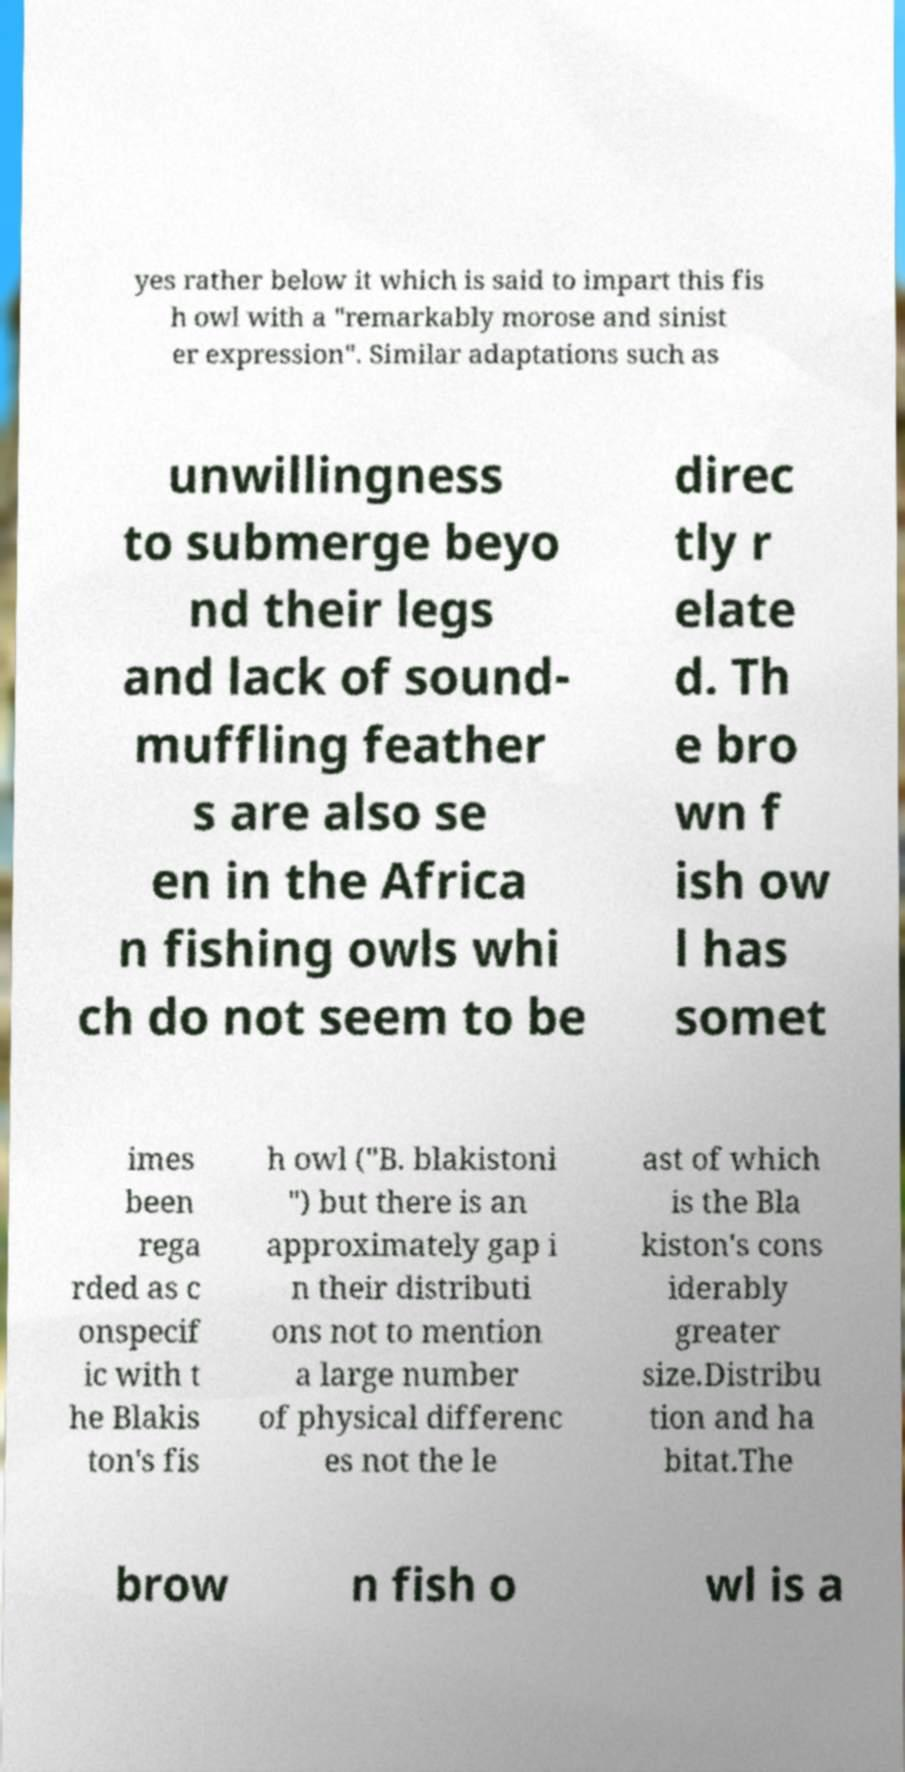Could you extract and type out the text from this image? yes rather below it which is said to impart this fis h owl with a "remarkably morose and sinist er expression". Similar adaptations such as unwillingness to submerge beyo nd their legs and lack of sound- muffling feather s are also se en in the Africa n fishing owls whi ch do not seem to be direc tly r elate d. Th e bro wn f ish ow l has somet imes been rega rded as c onspecif ic with t he Blakis ton's fis h owl ("B. blakistoni ") but there is an approximately gap i n their distributi ons not to mention a large number of physical differenc es not the le ast of which is the Bla kiston's cons iderably greater size.Distribu tion and ha bitat.The brow n fish o wl is a 